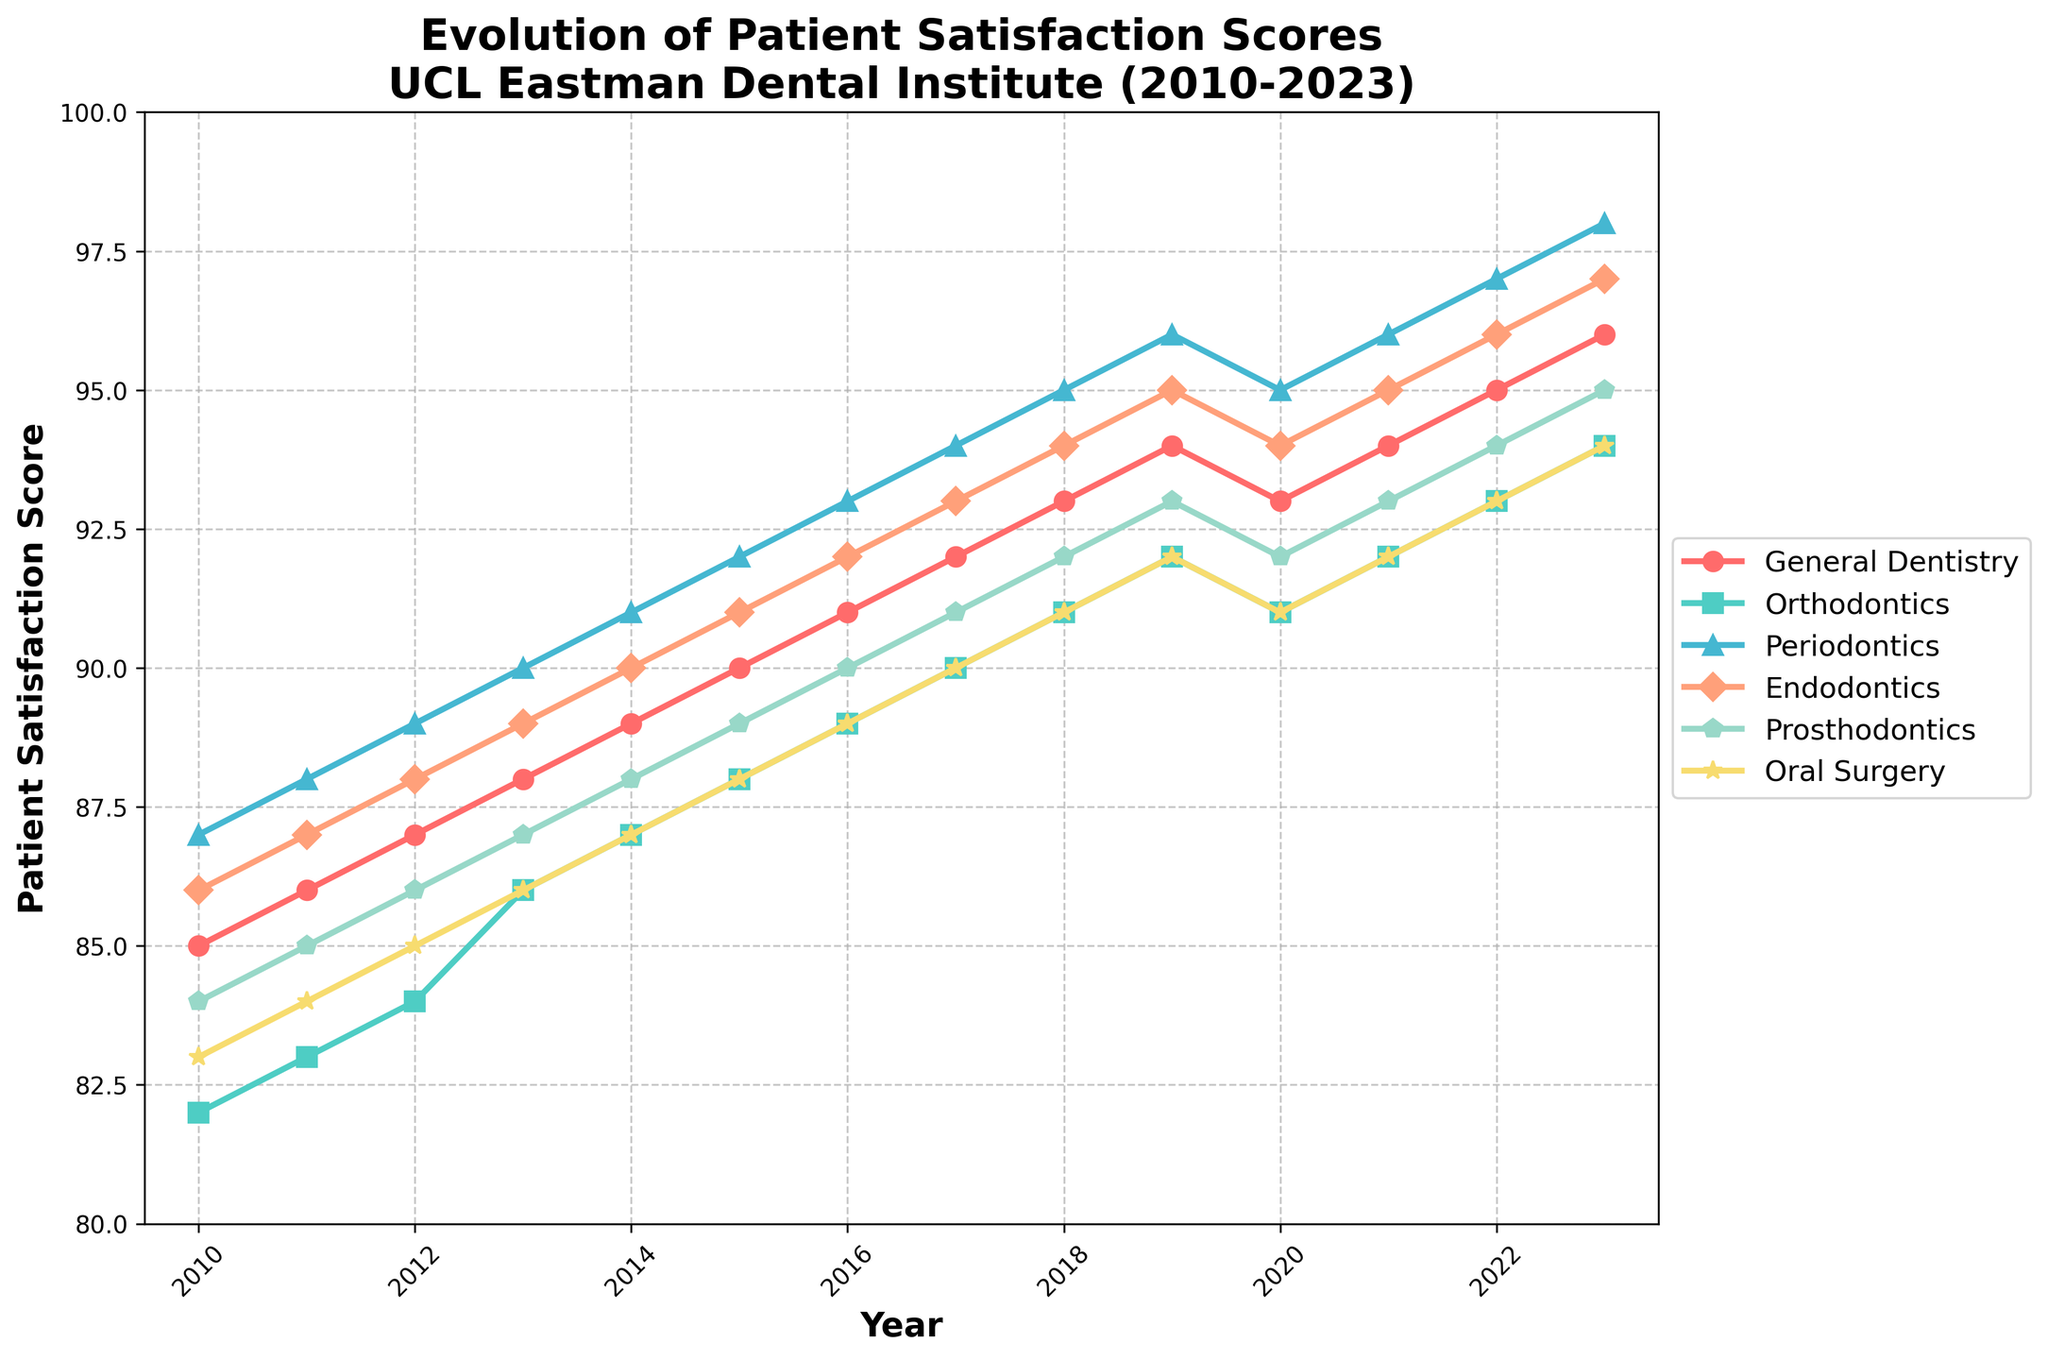What treatment type had the highest patient satisfaction score in 2013? Look at the values in 2013 for each treatment type and identify the highest score. Periodontics has a score of 90, which is the highest among all.
Answer: Periodontics How much did the patient satisfaction score for General Dentistry change from 2010 to 2023? Subtract the 2010 score from the 2023 score for General Dentistry: 96 - 85 = 11
Answer: 11 Which treatment type experienced the least variability in patient satisfaction scores from 2010 to 2023? Calculate the range (difference between max and min) for each treatment type. Orthodontics has scores ranging from 82 to 94, giving a range of 12, which is the smallest range compared to the other treatment types.
Answer: Orthodontics In which year did patient satisfaction for Oral Surgery return to its 2019 level following a decrease? Identify that the satisfaction score for Oral Surgery in 2019 is 92, it decreased in 2020 to 91, then returned to 92 in 2021.
Answer: 2021 How did the overall trend for Endodontics patient satisfaction evolve from 2010 to 2023? Observe that the score steadily increased each year, except for a slight dip in 2020, which then corrected itself by 2021: overall upward trend.
Answer: Upward By how many points did the highest and lowest satisfaction scores differ across all treatment types in 2023? Identify the highest score in 2023 (Periodontics, 98) and the lowest score in 2023 (Orthodontics, 94). Calculate the difference: 98 - 94 = 4
Answer: 4 What was the average patient satisfaction score for Prosthodontics over the given period? Sum the Prosthodontics scores from 2010 to 2023 (84 + 85 + 86 + 87 + 88 + 89 + 90 + 91 + 92 + 93 + 92 + 93 + 94 + 95) and divide by 14: (1285 / 14) ≈ 91.79
Answer: 91.79 Which year showed a noticeable increase in Orthodontics satisfaction score compared to the previous year? Analyze year-over-year changes; 2013 saw an increase from 84 to 86, which is a +2 increase compared to other years’ changes.
Answer: 2013 What can be inferred about the patient satisfaction trends for Periodontics and Oral Surgery? Both show a steady increase throughout the years, indicating improvements in service or patient care.
Answer: Steady increase Compare the satisfaction score trend for Prosthodontics and Oral Surgery between 2010 and 2023. Which one had a more significant improvement? Prosthodontics increased from 84 to 95 (an improvement of 11), while Oral Surgery increased from 83 to 94 (an improvement of 11). Both improved equally by 11 points.
Answer: Both same improvement 